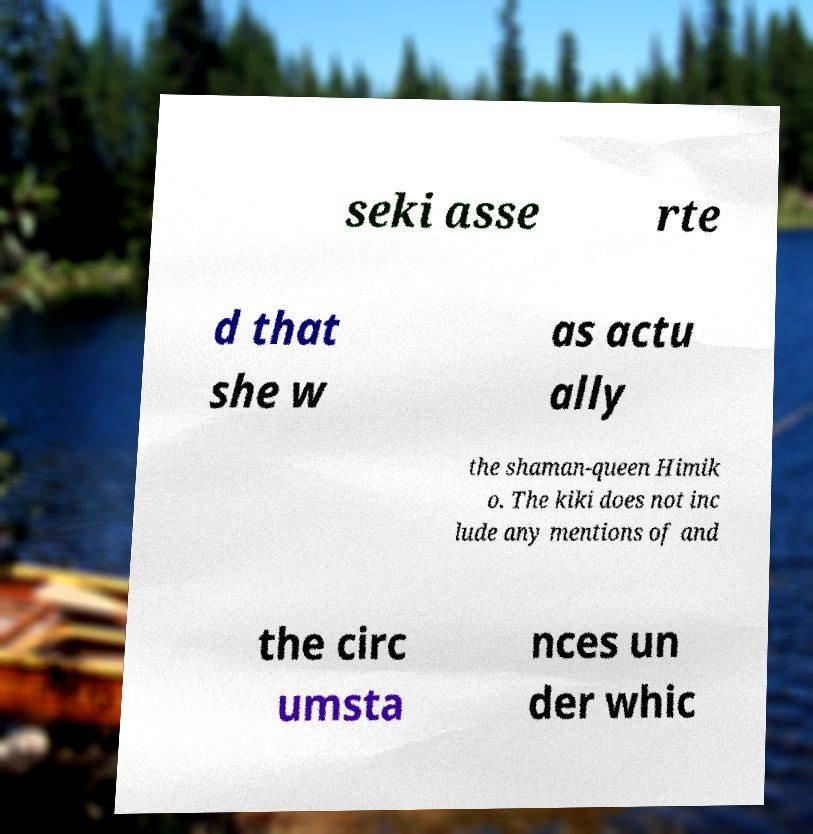There's text embedded in this image that I need extracted. Can you transcribe it verbatim? seki asse rte d that she w as actu ally the shaman-queen Himik o. The kiki does not inc lude any mentions of and the circ umsta nces un der whic 